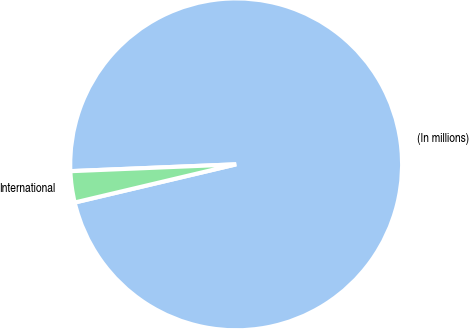<chart> <loc_0><loc_0><loc_500><loc_500><pie_chart><fcel>(In millions)<fcel>International<nl><fcel>96.96%<fcel>3.04%<nl></chart> 